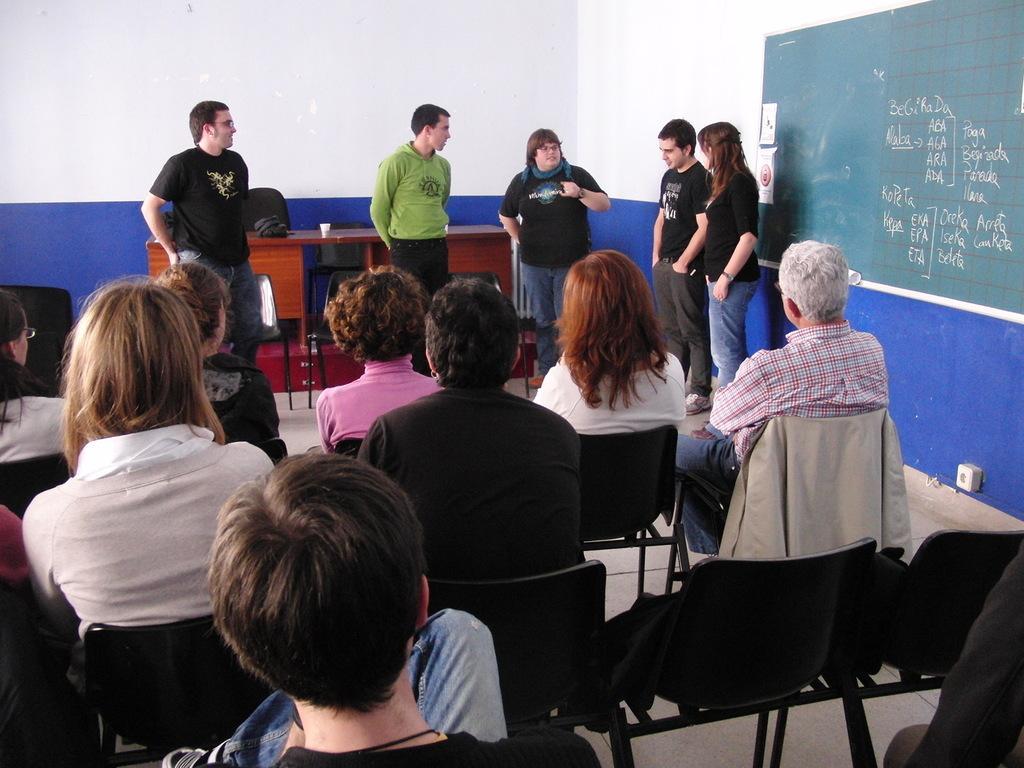How would you summarize this image in a sentence or two? In the picture it looks like a class room, there are a group of people sitting on chairs and in front of them some people are standing and on the right side there is a board attached to the wall, behind the people there is a table. 